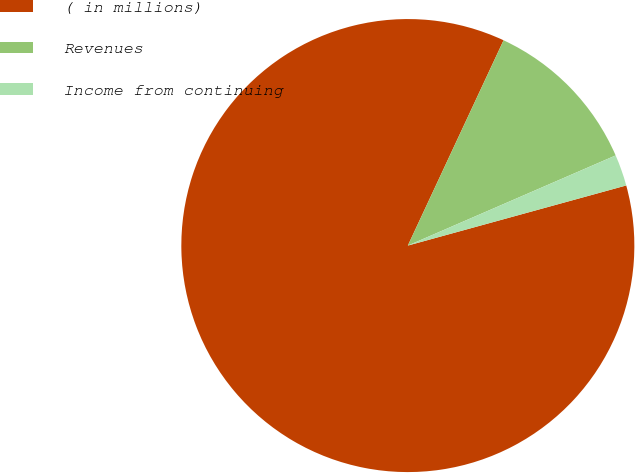<chart> <loc_0><loc_0><loc_500><loc_500><pie_chart><fcel>( in millions)<fcel>Revenues<fcel>Income from continuing<nl><fcel>86.22%<fcel>11.54%<fcel>2.24%<nl></chart> 